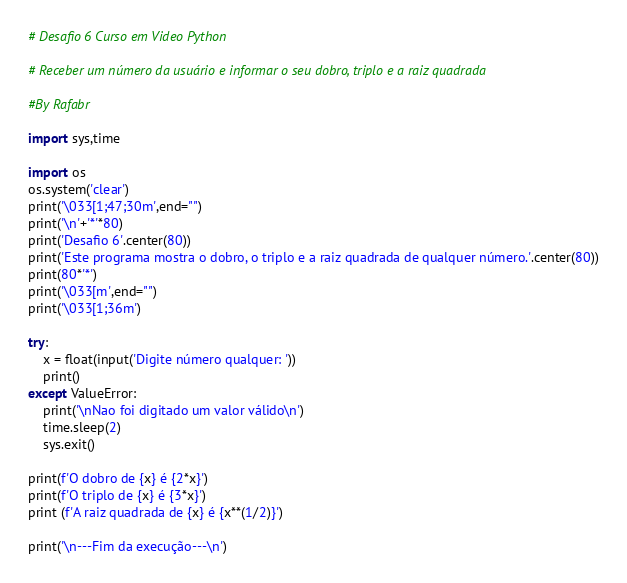<code> <loc_0><loc_0><loc_500><loc_500><_Python_># Desafio 6 Curso em Video Python

# Receber um número da usuário e informar o seu dobro, triplo e a raiz quadrada

#By Rafabr

import sys,time

import os
os.system('clear')
print('\033[1;47;30m',end="")
print('\n'+'*'*80)
print('Desafio 6'.center(80))
print('Este programa mostra o dobro, o triplo e a raiz quadrada de qualquer número.'.center(80))
print(80*'*')
print('\033[m',end="")
print('\033[1;36m')

try:
    x = float(input('Digite número qualquer: '))
    print()
except ValueError:
    print('\nNao foi digitado um valor válido\n')
    time.sleep(2)
    sys.exit()

print(f'O dobro de {x} é {2*x}')
print(f'O triplo de {x} é {3*x}')
print (f'A raiz quadrada de {x} é {x**(1/2)}')

print('\n---Fim da execução---\n')</code> 